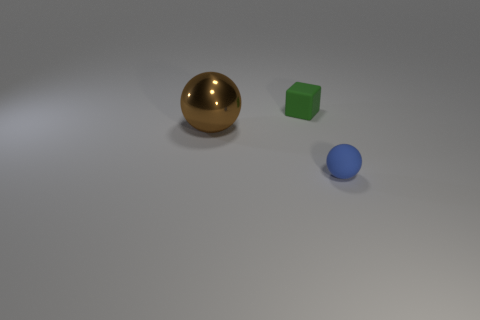Is the shape of the brown thing the same as the matte thing that is left of the tiny blue thing?
Offer a terse response. No. How big is the sphere that is behind the object that is to the right of the tiny green object?
Your answer should be very brief. Large. Are there the same number of things in front of the metallic ball and small cubes to the right of the green matte block?
Give a very brief answer. No. There is a big object that is the same shape as the small blue thing; what color is it?
Your answer should be compact. Brown. How many tiny rubber blocks have the same color as the small matte ball?
Your response must be concise. 0. Does the small thing in front of the small matte cube have the same shape as the small green matte object?
Give a very brief answer. No. There is a tiny thing that is behind the big metal sphere that is left of the small rubber thing in front of the metal thing; what is its shape?
Ensure brevity in your answer.  Cube. What is the size of the rubber block?
Provide a short and direct response. Small. What is the color of the other small thing that is the same material as the small blue object?
Offer a very short reply. Green. How many brown spheres are made of the same material as the large brown object?
Make the answer very short. 0. 